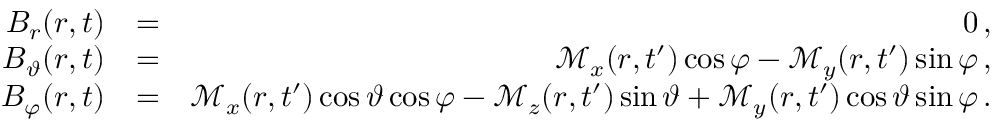<formula> <loc_0><loc_0><loc_500><loc_500>\begin{array} { r l r } { B _ { r } ( r , t ) } & { = } & { 0 \, , } \\ { B _ { \vartheta } ( r , t ) } & { = } & { \mathcal { M } _ { x } ( r , t ^ { \prime } ) \cos \varphi - \mathcal { M } _ { y } ( r , t ^ { \prime } ) \sin \varphi \, , } \\ { B _ { \varphi } ( r , t ) } & { = } & { \mathcal { M } _ { x } ( r , t ^ { \prime } ) \cos \vartheta \cos \varphi - \mathcal { M } _ { z } ( r , t ^ { \prime } ) \sin \vartheta + \mathcal { M } _ { y } ( r , t ^ { \prime } ) \cos \vartheta \sin \varphi \, . } \end{array}</formula> 